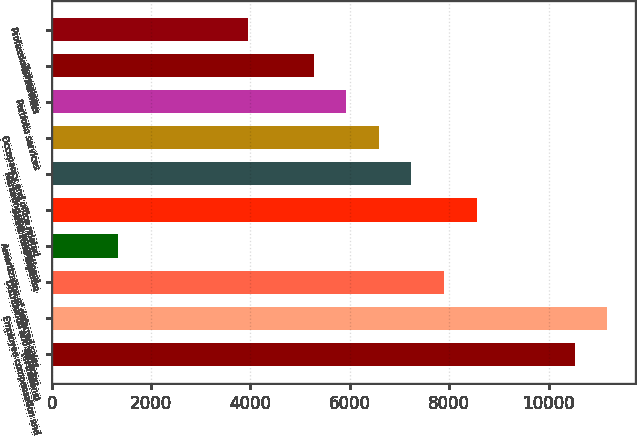Convert chart. <chart><loc_0><loc_0><loc_500><loc_500><bar_chart><fcel>(in millions)<fcel>Employee compensation and<fcel>Distribution and servicing<fcel>Amortization of deferred sales<fcel>Direct fund expense<fcel>Marketing and promotional<fcel>Occupancy and office related<fcel>Portfolio services<fcel>Technology<fcel>Professional services<nl><fcel>10523.4<fcel>11179.8<fcel>7897.8<fcel>1333.8<fcel>8554.2<fcel>7241.4<fcel>6585<fcel>5928.6<fcel>5272.2<fcel>3959.4<nl></chart> 